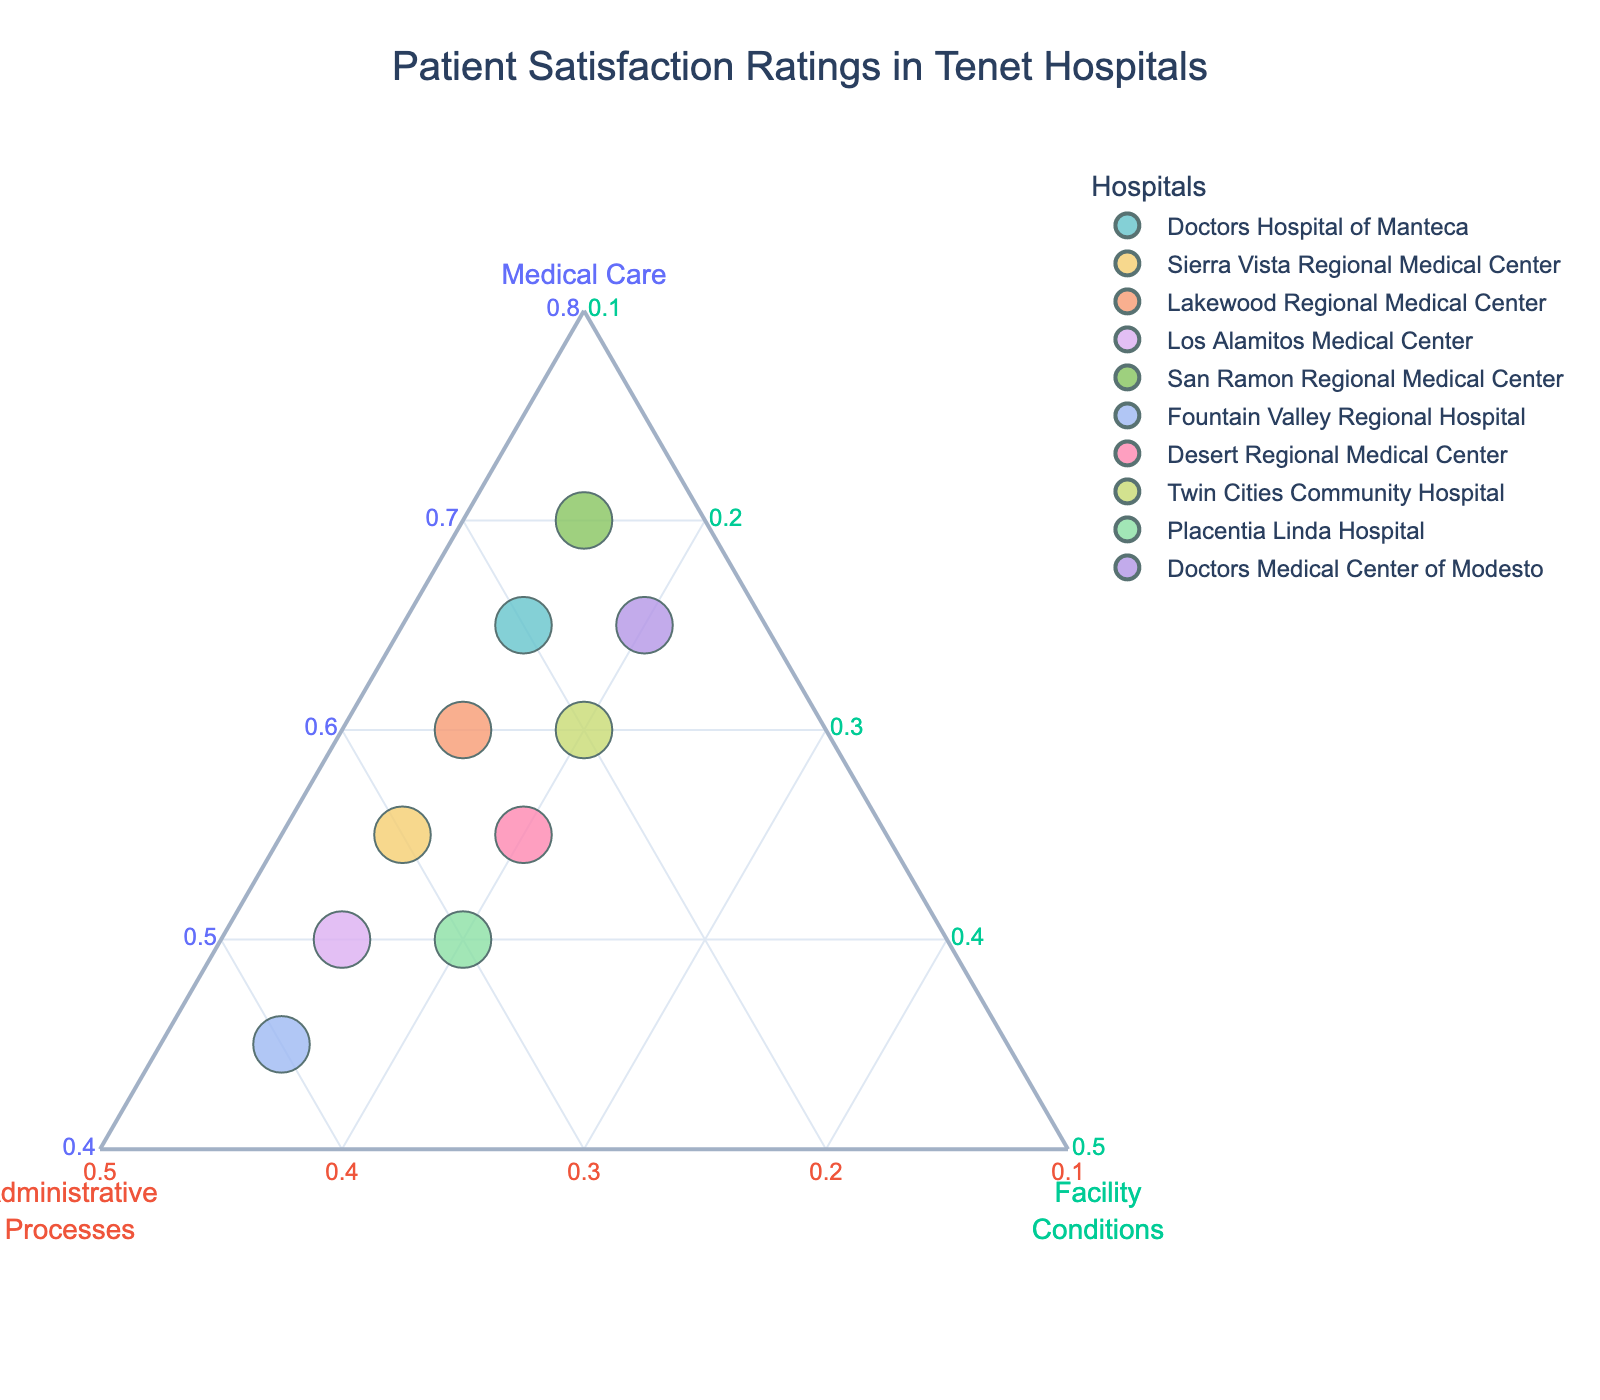What hospital has the highest percentage of satisfaction in Medical Care? From the plot, you can identify the position on the `Medical Care` axis. The hospital data point at the highest value there corresponds to the highest percentage of Medical Care satisfaction.
Answer: San Ramon Regional Medical Center What is the range of satisfaction percentages for Administrative Processes across the hospitals? Identify the lowest and highest values on the `Administrative Processes` axis by observing the data points' positions. Calculate the difference to find the range.
Answer: 15% to 40% Is there any hospital with satisfaction percentages equally distributed among the three factors? Look for a data point that is positioned equally between the three axes, indicating an equal distribution.
Answer: No Do any hospitals have a higher percentage of Facility Conditions compared to Administrative Processes? Compare the positions of the data points on the `Facility Conditions` axis with their positions on the `Administrative Processes` axis. Check if any have `Facility Conditions` values higher than `Administrative Processes`.
Answer: No For the hospital with the highest satisfaction in Administrative Processes, how does its Medical Care satisfaction compare? Locate the hospital with the highest value on the `Administrative Processes` axis and then compare its corresponding Medical Care value on the `Medical Care` axis.
Answer: Fountain Valley Regional Hospital, lower Medical Care What's the average satisfaction percentage for Facility Conditions across all hospitals? Sum all the percentages of Facility Conditions for each hospital and divide by the number of hospitals. (20+15+15+15+15+15+20+20+20+20) / 10 = 17.5%
Answer: 17.5% Which hospital has the closest balance of satisfaction across all three factors? Look for the data point closest to the center of the ternary plot as it would represent a balance among the three satisfaction factors.
Answer: Desert Regional Medical Center How do Medical Care satisfaction percentages vary across all hospitals? Look along the axis labeled `Medical Care` and note the spread of the data points to understand the variation.
Answer: Ranges from 45% to 70% Which factor generally receives the lowest satisfaction percentages across most hospitals? Observe which axis consistently has data points with the lowest values compared to the other two axes.
Answer: Facility Conditions 